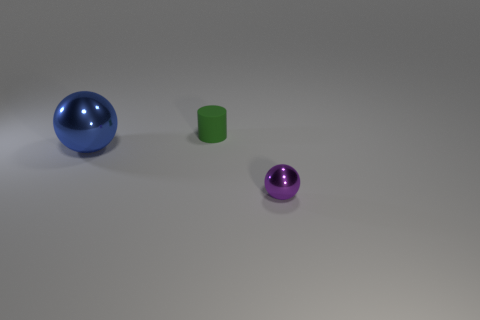Add 3 purple shiny spheres. How many objects exist? 6 Subtract all spheres. How many objects are left? 1 Subtract all large cyan cylinders. Subtract all tiny purple shiny objects. How many objects are left? 2 Add 2 purple metallic things. How many purple metallic things are left? 3 Add 1 large cylinders. How many large cylinders exist? 1 Subtract 0 gray cylinders. How many objects are left? 3 